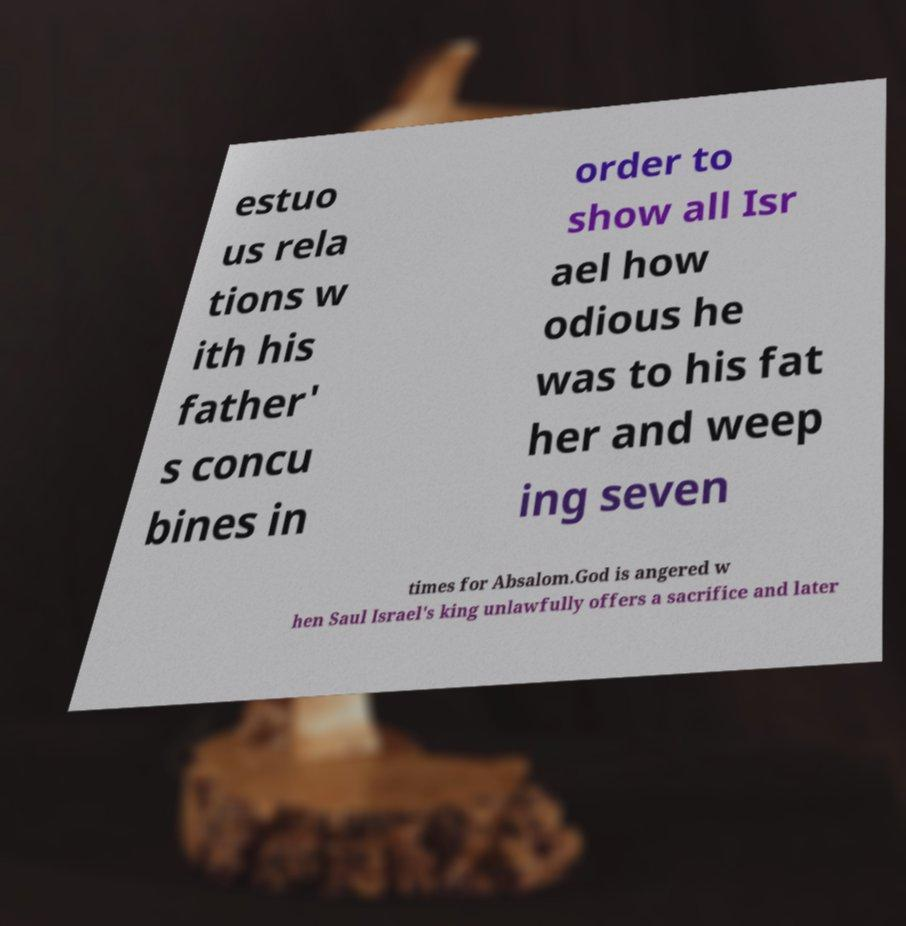Could you extract and type out the text from this image? estuo us rela tions w ith his father' s concu bines in order to show all Isr ael how odious he was to his fat her and weep ing seven times for Absalom.God is angered w hen Saul Israel's king unlawfully offers a sacrifice and later 